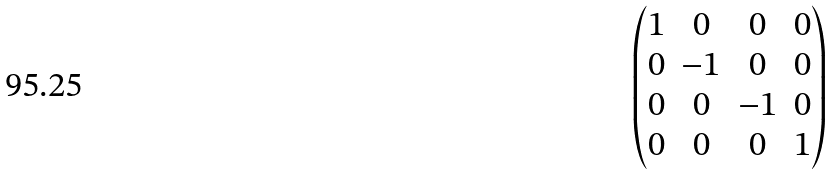Convert formula to latex. <formula><loc_0><loc_0><loc_500><loc_500>\begin{pmatrix} 1 & 0 & 0 & 0 \\ 0 & - 1 & 0 & 0 \\ 0 & 0 & - 1 & 0 \\ 0 & 0 & 0 & 1 \end{pmatrix}</formula> 